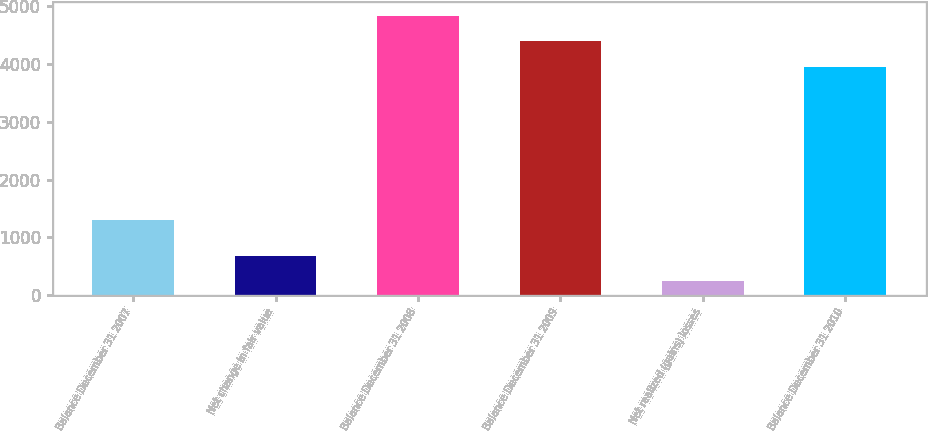Convert chart. <chart><loc_0><loc_0><loc_500><loc_500><bar_chart><fcel>Balance December 31 2007<fcel>Net change in fair value<fcel>Balance December 31 2008<fcel>Balance December 31 2009<fcel>Net realized (gains) losses<fcel>Balance December 31 2010<nl><fcel>1301<fcel>688.3<fcel>4825.6<fcel>4386.3<fcel>249<fcel>3947<nl></chart> 